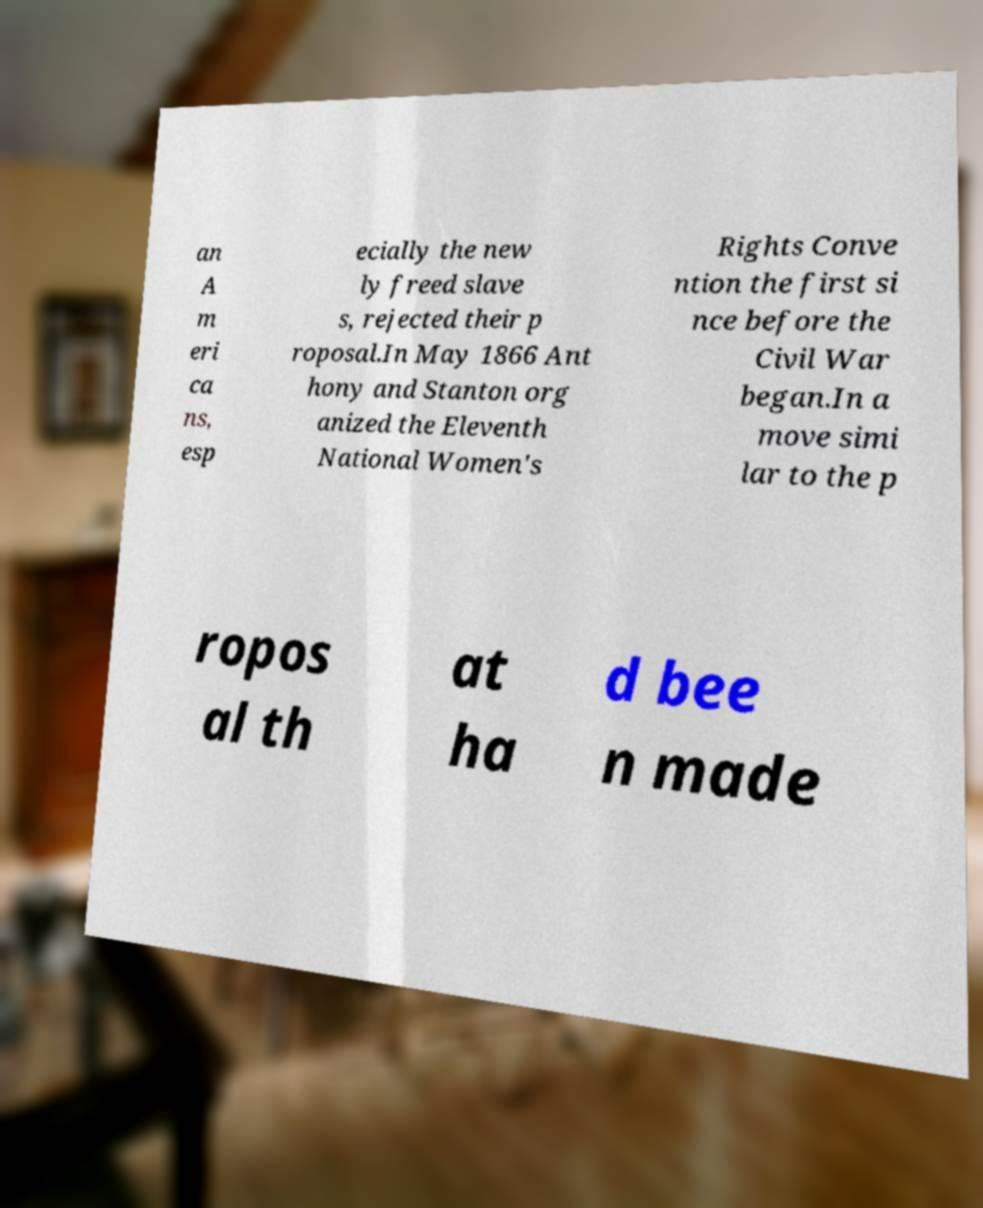Can you read and provide the text displayed in the image?This photo seems to have some interesting text. Can you extract and type it out for me? an A m eri ca ns, esp ecially the new ly freed slave s, rejected their p roposal.In May 1866 Ant hony and Stanton org anized the Eleventh National Women's Rights Conve ntion the first si nce before the Civil War began.In a move simi lar to the p ropos al th at ha d bee n made 